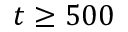Convert formula to latex. <formula><loc_0><loc_0><loc_500><loc_500>t \geq 5 0 0</formula> 